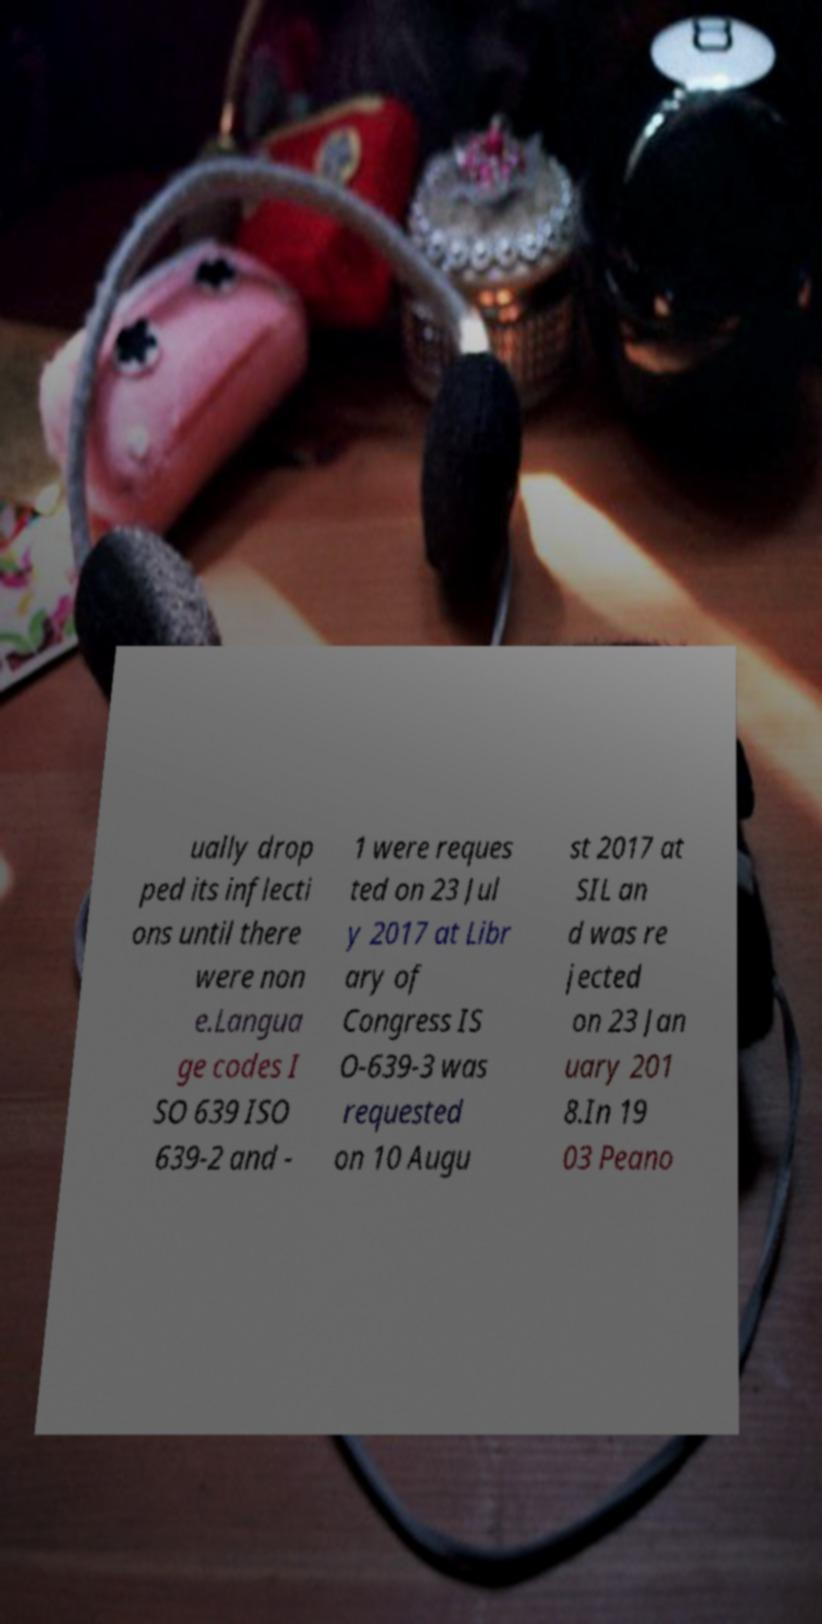Could you extract and type out the text from this image? ually drop ped its inflecti ons until there were non e.Langua ge codes I SO 639 ISO 639-2 and - 1 were reques ted on 23 Jul y 2017 at Libr ary of Congress IS O-639-3 was requested on 10 Augu st 2017 at SIL an d was re jected on 23 Jan uary 201 8.In 19 03 Peano 